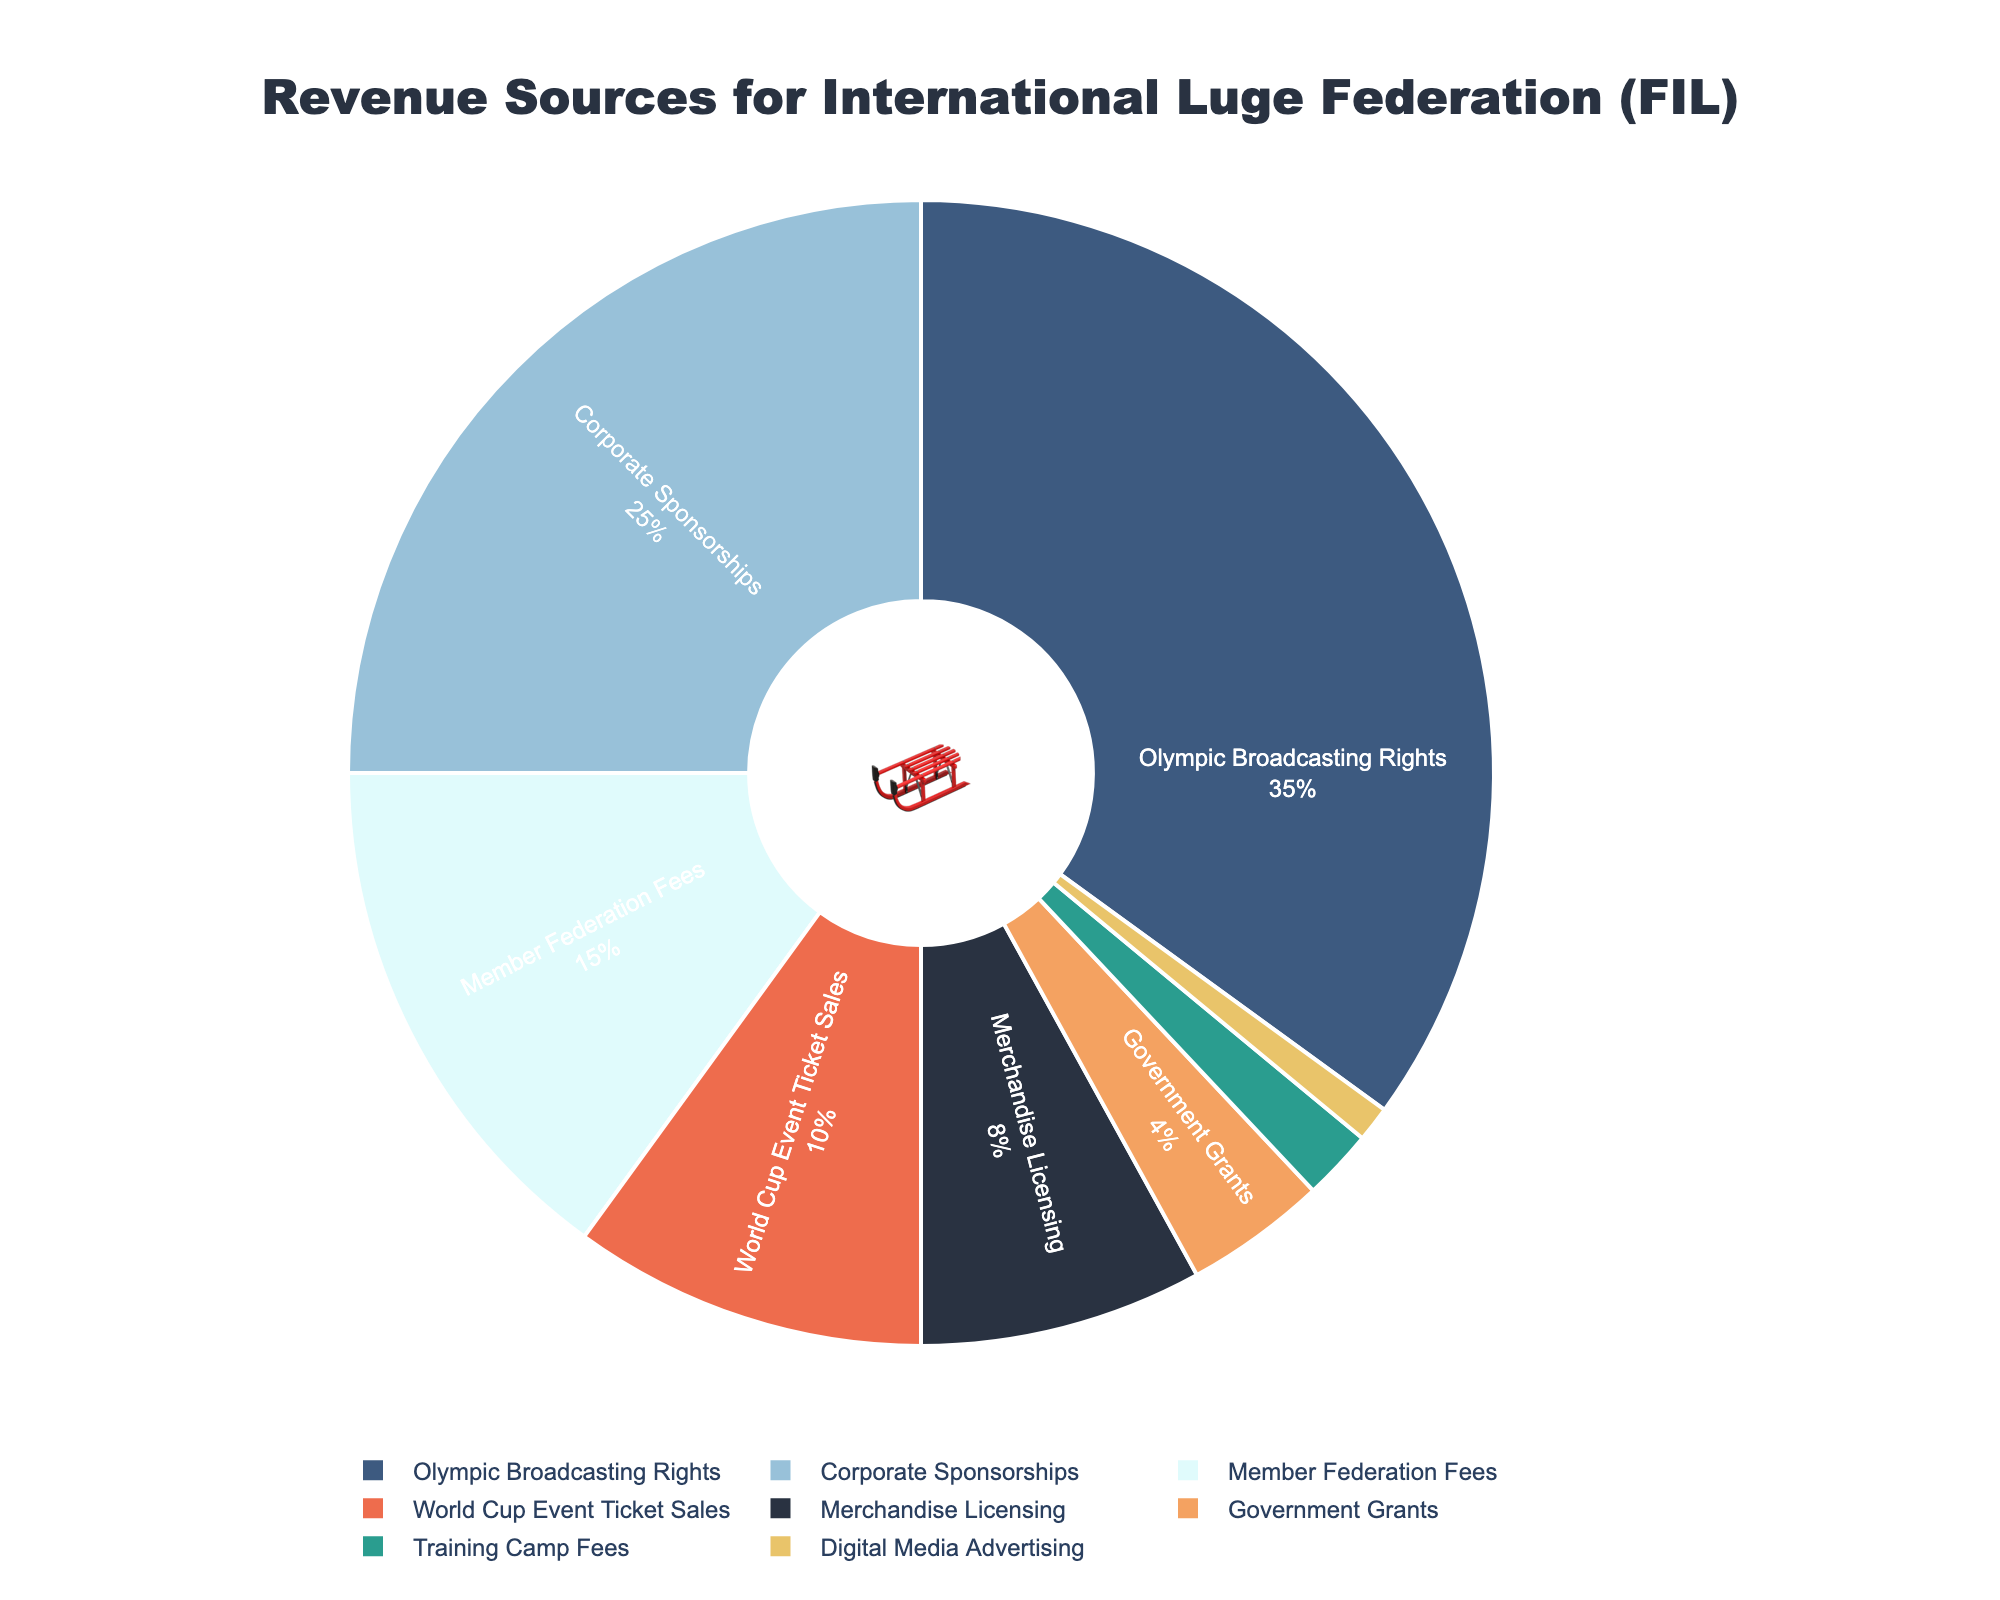What percentage of the revenue comes from Corporate Sponsorships? The pie chart shows the percentage breakdown of various revenue sources for the International Luge Federation (FIL). The slice labeled "Corporate Sponsorships" indicates its percentage.
Answer: 25% Which revenue source contributes the least to the FIL? Looking at the pie chart, the segment with the smallest slice represents the revenue source that contributes the least, which is labeled "Digital Media Advertising".
Answer: Digital Media Advertising Is the combined revenue from Olympic Broadcasting Rights and World Cup Event Ticket Sales greater than 40%? First, note the percentages of Olympic Broadcasting Rights (35%) and World Cup Event Ticket Sales (10%). Add these together: 35% + 10% = 45%. Since 45% is greater than 40%, the answer is yes.
Answer: Yes What revenue source is represented by the orange color? The pie chart uses different colors for different revenue sources, and the slice with the orange color is labeled "World Cup Event Ticket Sales".
Answer: World Cup Event Ticket Sales Are Training Camp Fees and Digital Media Advertising collectively less than Merchandise Licensing? Add the percentages of Training Camp Fees (2%) and Digital Media Advertising (1%): 2% + 1% = 3%. Merchandise Licensing is 8%, and 3% is less than 8%, so the answer is yes.
Answer: Yes What percentage of revenue does Merchandise Licensing contribute? The pie chart shows the percentage breakdown for various sources, and the slice labeled "Merchandise Licensing" represents its contribution.
Answer: 8% Which is greater, the revenue from Government Grants or Training Camp Fees, and by how much? Compare the percentages: Government Grants (4%) and Training Camp Fees (2%). The difference is calculated as 4% - 2% = 2%. Government Grants are greater by 2%.
Answer: Government Grants by 2% What is the total percentage of revenue coming from World Cup Event Ticket Sales, Merchandise Licensing, and Government Grants combined? To find the total, add the percentages for World Cup Event Ticket Sales (10%), Merchandise Licensing (8%), and Government Grants (4%): 10% + 8% + 4% = 22%.
Answer: 22% 